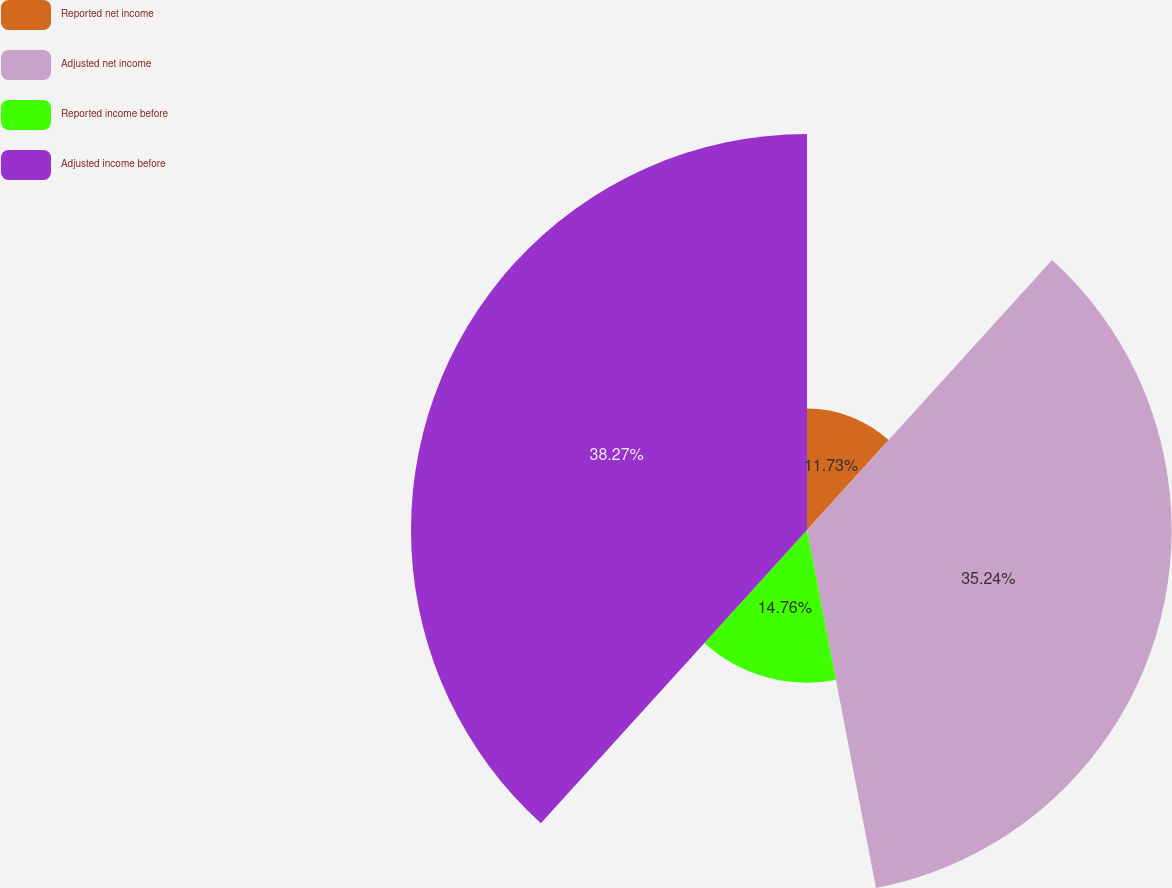Convert chart to OTSL. <chart><loc_0><loc_0><loc_500><loc_500><pie_chart><fcel>Reported net income<fcel>Adjusted net income<fcel>Reported income before<fcel>Adjusted income before<nl><fcel>11.73%<fcel>35.24%<fcel>14.76%<fcel>38.27%<nl></chart> 